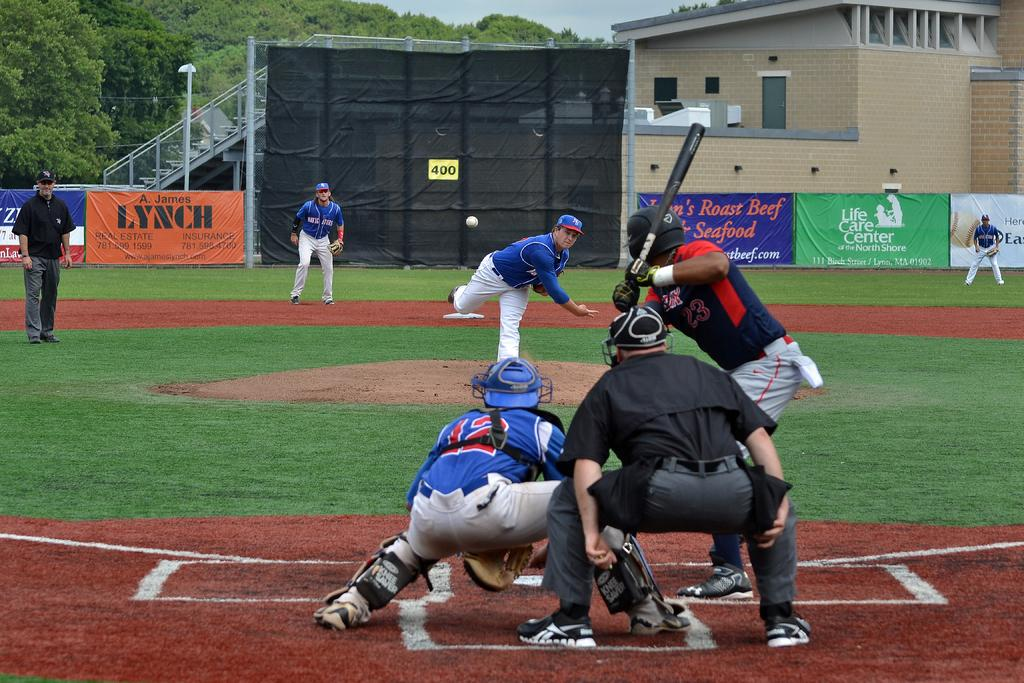Provide a one-sentence caption for the provided image. A baseball player wearing the number 23 watches a pitch and prepares to swing. 